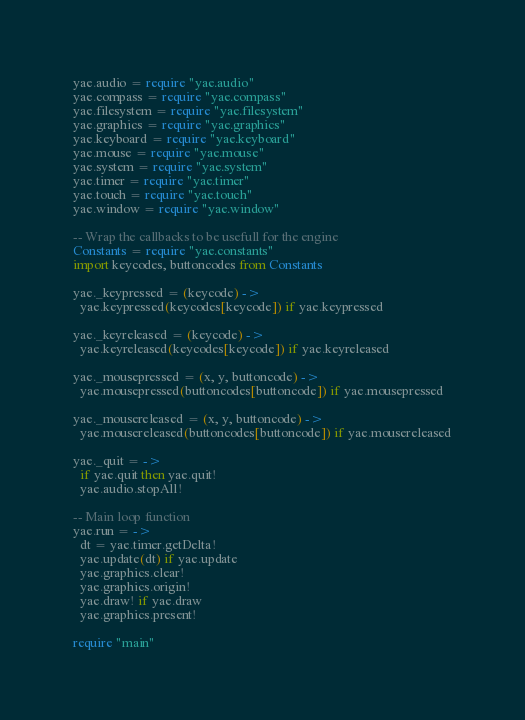<code> <loc_0><loc_0><loc_500><loc_500><_MoonScript_>yae.audio = require "yae.audio"
yae.compass = require "yae.compass"
yae.filesystem = require "yae.filesystem"
yae.graphics = require "yae.graphics"
yae.keyboard = require "yae.keyboard"
yae.mouse = require "yae.mouse"
yae.system = require "yae.system"
yae.timer = require "yae.timer"
yae.touch = require "yae.touch"
yae.window = require "yae.window"

-- Wrap the callbacks to be usefull for the engine
Constants = require "yae.constants"
import keycodes, buttoncodes from Constants

yae._keypressed = (keycode) ->
  yae.keypressed(keycodes[keycode]) if yae.keypressed

yae._keyreleased = (keycode) ->
  yae.keyreleased(keycodes[keycode]) if yae.keyreleased

yae._mousepressed = (x, y, buttoncode) ->
  yae.mousepressed(buttoncodes[buttoncode]) if yae.mousepressed

yae._mousereleased = (x, y, buttoncode) ->
  yae.mousereleased(buttoncodes[buttoncode]) if yae.mousereleased

yae._quit = ->
  if yae.quit then yae.quit!
  yae.audio.stopAll!

-- Main loop function
yae.run = ->
  dt = yae.timer.getDelta!
  yae.update(dt) if yae.update
  yae.graphics.clear!
  yae.graphics.origin!
  yae.draw! if yae.draw
  yae.graphics.present!

require "main"
</code> 